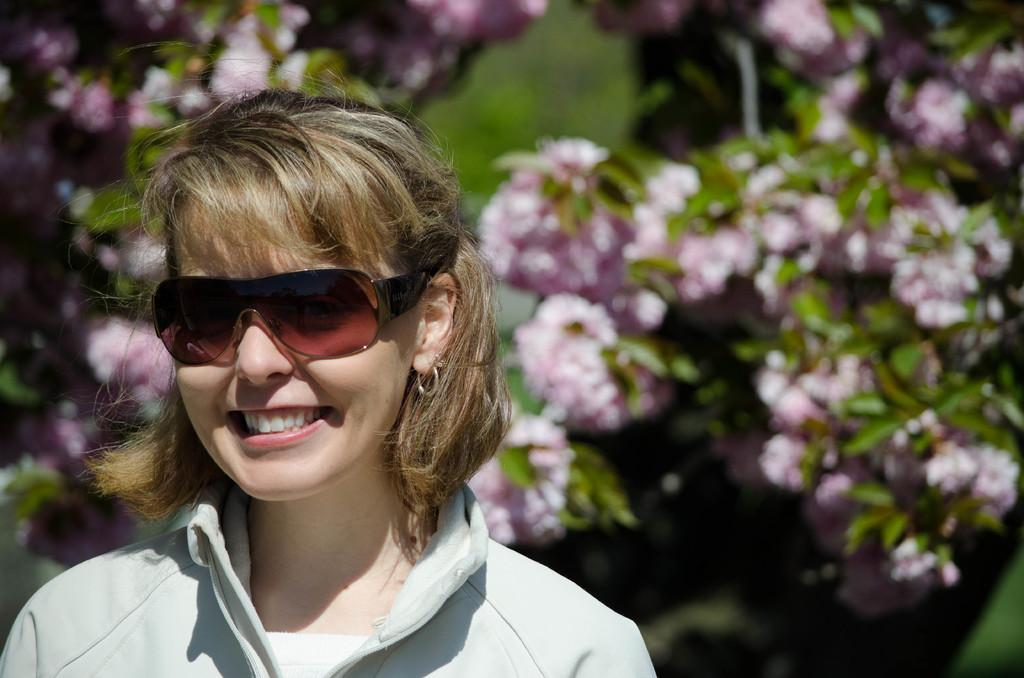What type of plants can be seen in the background of the image? There are pink flowers and green leaves in the background of the image. Who is present in the image? There is a woman in the image. Can you describe the woman's hair? The woman has short, light brown hair. What is the woman wearing on her face? The woman is wearing goggles. What expression does the woman have? The woman is smiling. How many cans of paint does the woman have in the image? There is no mention of cans of paint in the image; the woman is wearing goggles, but there is no indication of painting activity. 